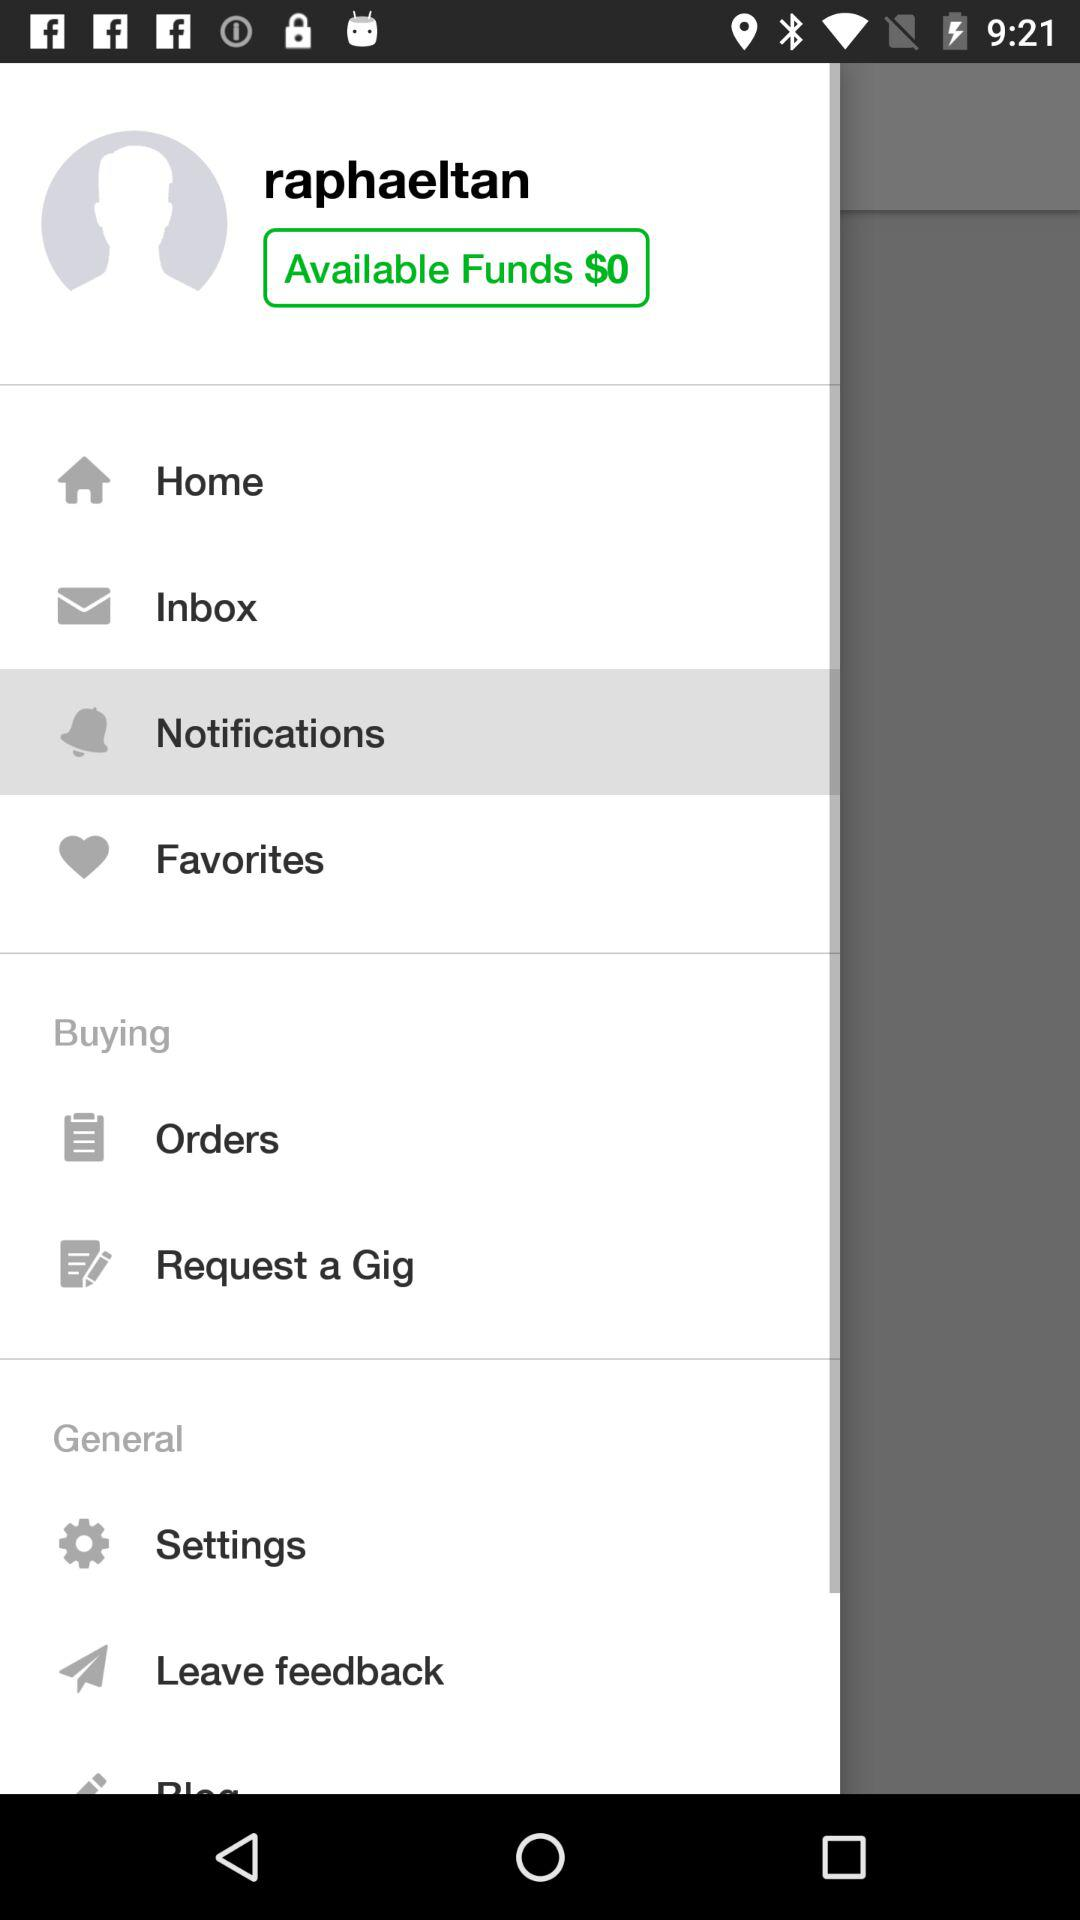Which option has been selected? The selected option is "Notifications". 